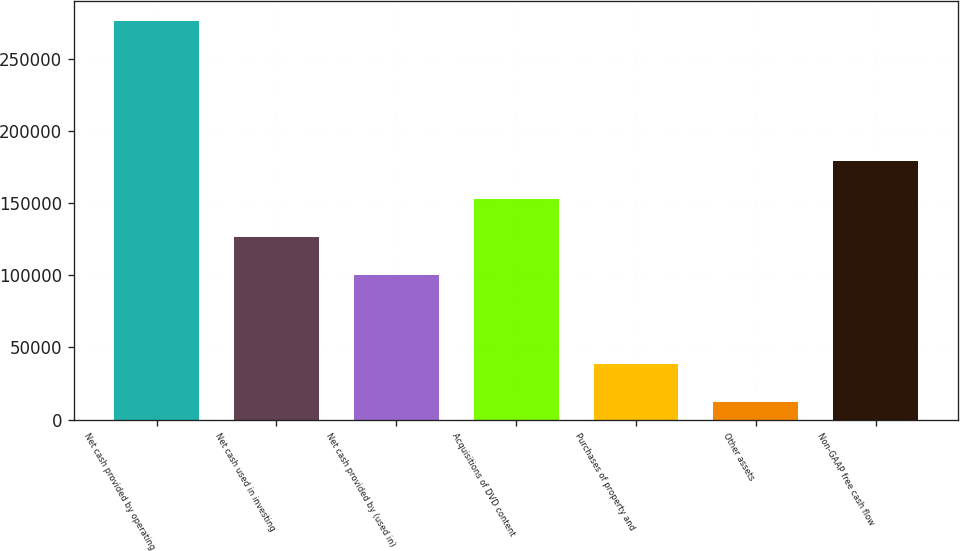<chart> <loc_0><loc_0><loc_500><loc_500><bar_chart><fcel>Net cash provided by operating<fcel>Net cash used in investing<fcel>Net cash provided by (used in)<fcel>Acquisitions of DVD content<fcel>Purchases of property and<fcel>Other assets<fcel>Non-GAAP free cash flow<nl><fcel>276401<fcel>126451<fcel>100045<fcel>152856<fcel>38749.7<fcel>12344<fcel>179262<nl></chart> 